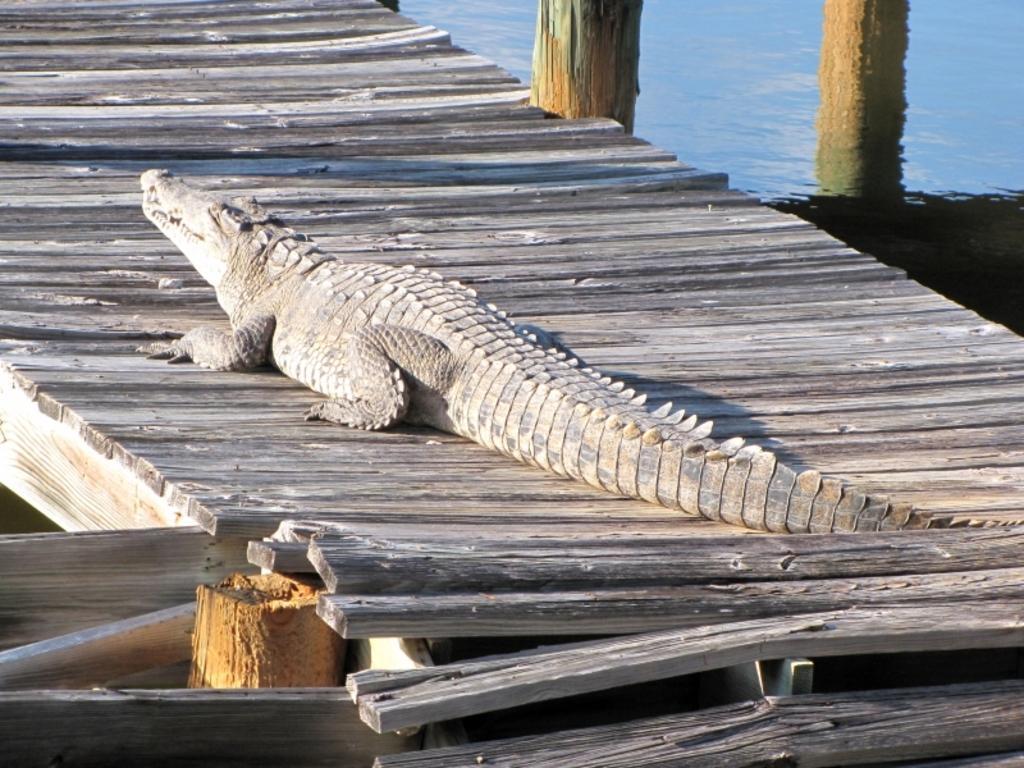Describe this image in one or two sentences. This picture is clicked outside the city. In the center there is a crocodile on the wooden planks. In the background there is a water body and the poles. 